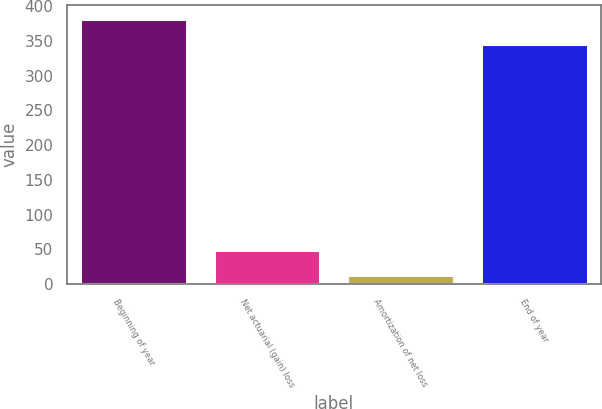<chart> <loc_0><loc_0><loc_500><loc_500><bar_chart><fcel>Beginning of year<fcel>Net actuarial (gain) loss<fcel>Amortization of net loss<fcel>End of year<nl><fcel>382.1<fcel>49.1<fcel>13<fcel>346<nl></chart> 